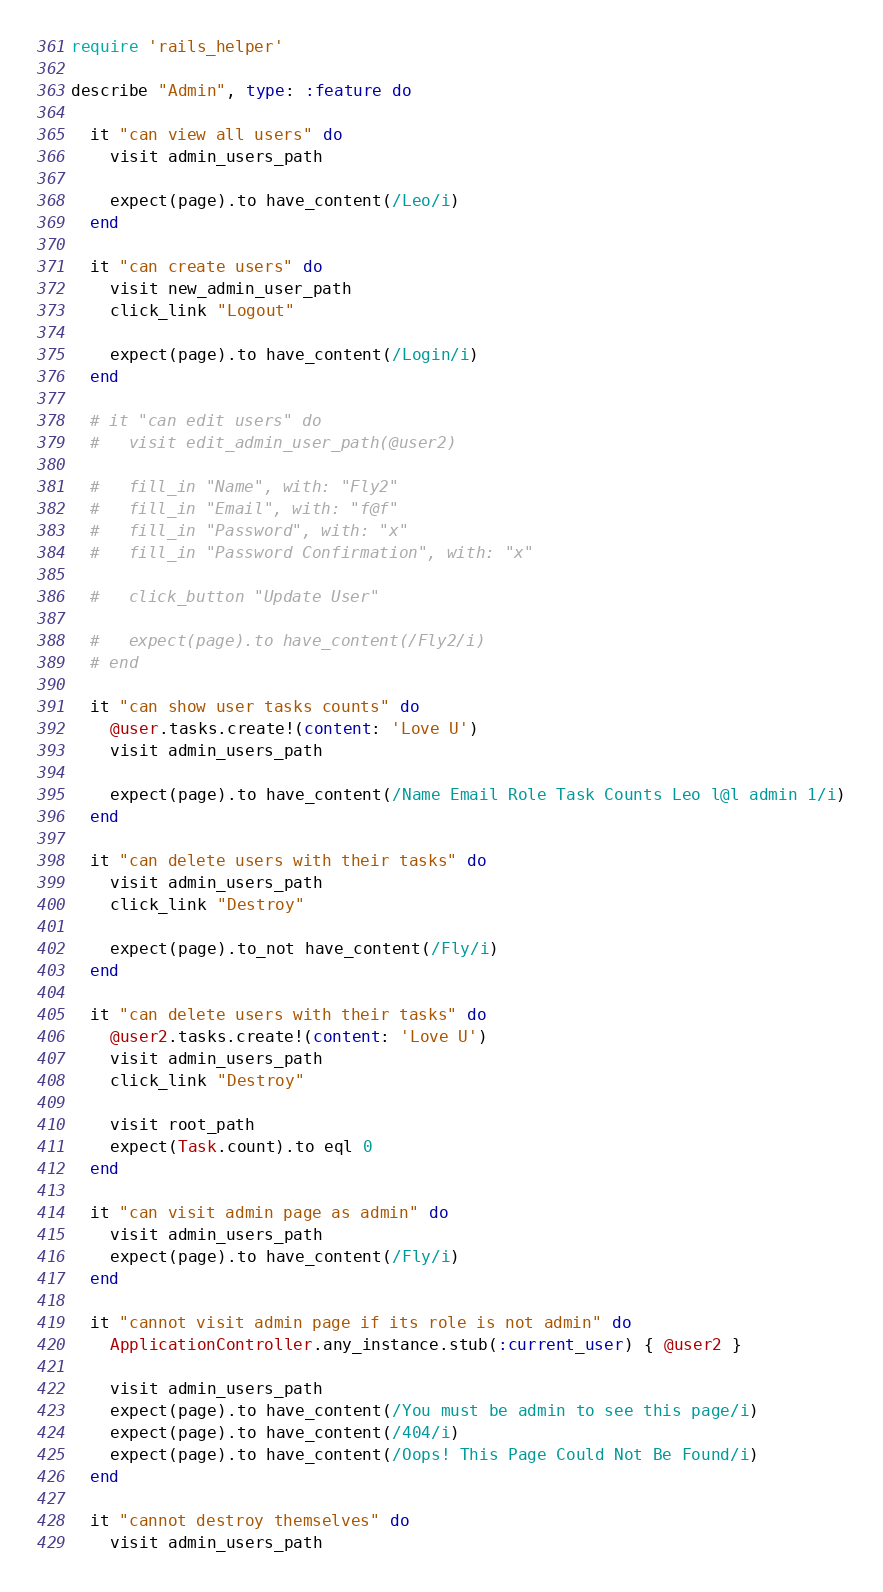<code> <loc_0><loc_0><loc_500><loc_500><_Ruby_>require 'rails_helper'

describe "Admin", type: :feature do   

  it "can view all users" do
    visit admin_users_path

    expect(page).to have_content(/Leo/i)
  end

  it "can create users" do
    visit new_admin_user_path
    click_link "Logout"

    expect(page).to have_content(/Login/i)
  end  

  # it "can edit users" do
  #   visit edit_admin_user_path(@user2)
 
  #   fill_in "Name", with: "Fly2"
  #   fill_in "Email", with: "f@f"
  #   fill_in "Password", with: "x"
  #   fill_in "Password Confirmation", with: "x"

  #   click_button "Update User"

  #   expect(page).to have_content(/Fly2/i)
  # end  

  it "can show user tasks counts" do
    @user.tasks.create!(content: 'Love U')
    visit admin_users_path

    expect(page).to have_content(/Name Email Role Task Counts Leo l@l admin 1/i)
  end

  it "can delete users with their tasks" do
    visit admin_users_path
    click_link "Destroy"

    expect(page).to_not have_content(/Fly/i)
  end 

  it "can delete users with their tasks" do
    @user2.tasks.create!(content: 'Love U')
    visit admin_users_path
    click_link "Destroy"

    visit root_path
    expect(Task.count).to eql 0
  end

  it "can visit admin page as admin" do
    visit admin_users_path
    expect(page).to have_content(/Fly/i)
  end

  it "cannot visit admin page if its role is not admin" do
    ApplicationController.any_instance.stub(:current_user) { @user2 }

    visit admin_users_path
    expect(page).to have_content(/You must be admin to see this page/i)
    expect(page).to have_content(/404/i)
    expect(page).to have_content(/Oops! This Page Could Not Be Found/i)
  end

  it "cannot destroy themselves" do
    visit admin_users_path
</code> 